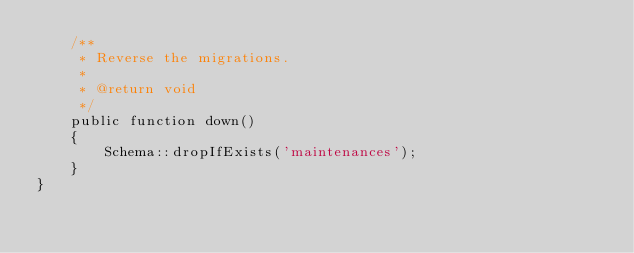Convert code to text. <code><loc_0><loc_0><loc_500><loc_500><_PHP_>    /**
     * Reverse the migrations.
     *
     * @return void
     */
    public function down()
    {
        Schema::dropIfExists('maintenances');
    }
}
</code> 